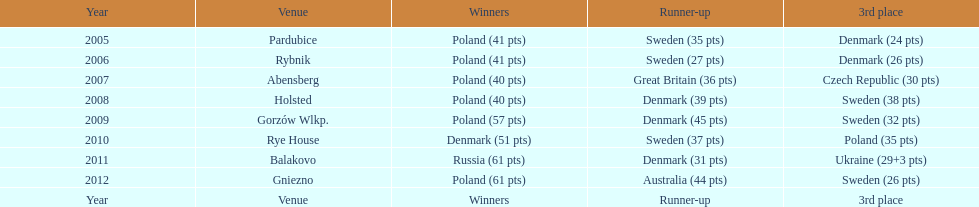In which year did poland first miss out on the top three rankings in the team speedway junior world championship? 2011. 